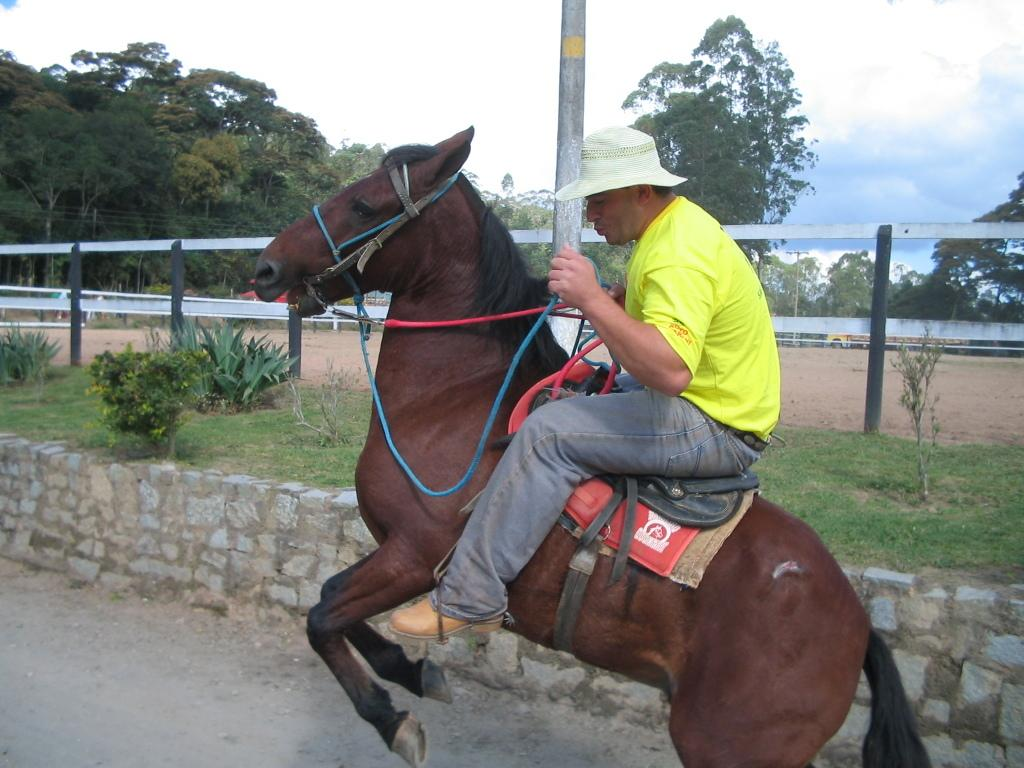What is the main subject of the image? There is a person in the image. What is the person doing in the image? The person is riding a brown horse. Can you describe the person's attire in the image? The person is wearing a hat. What structures can be seen in the image? There is a fence and a pole in the image. What can be seen in the background of the image? There are trees in the background of the image. What type of prose is being recited by the person in the image? There is no indication in the image that the person is reciting any prose. Can you describe the snake that is coiled around the person's leg in the image? There is no snake present in the image; the person is riding a brown horse. 